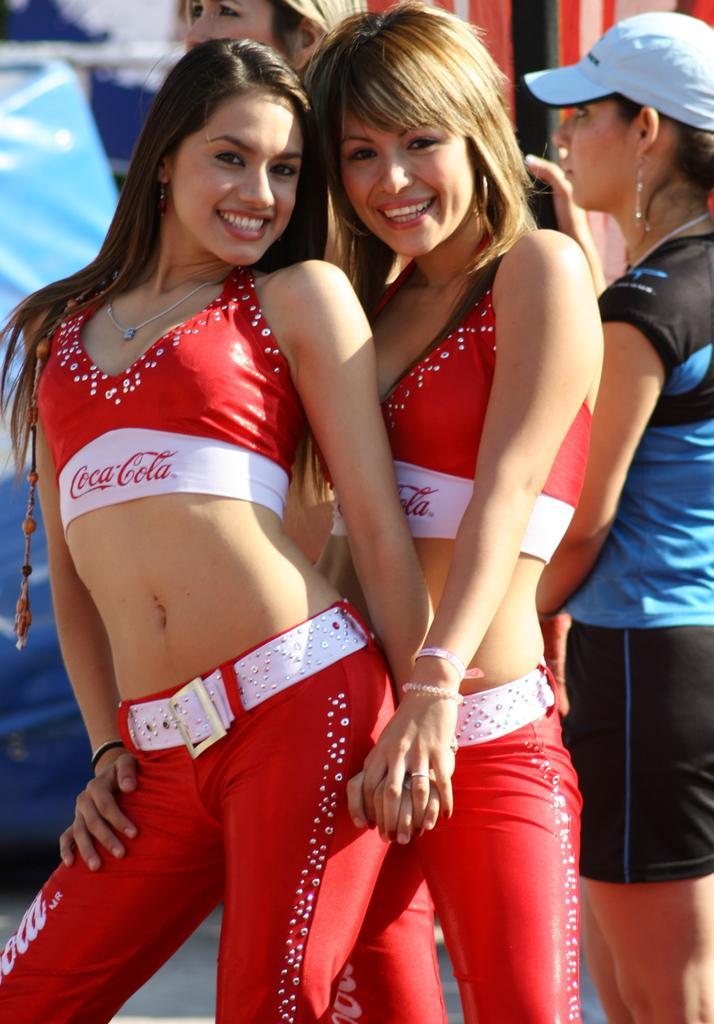Describe this image in one or two sentences. In this image in the front there are women standing and smiling. In the background there are persons and there are objects which are blue and red in colour. 